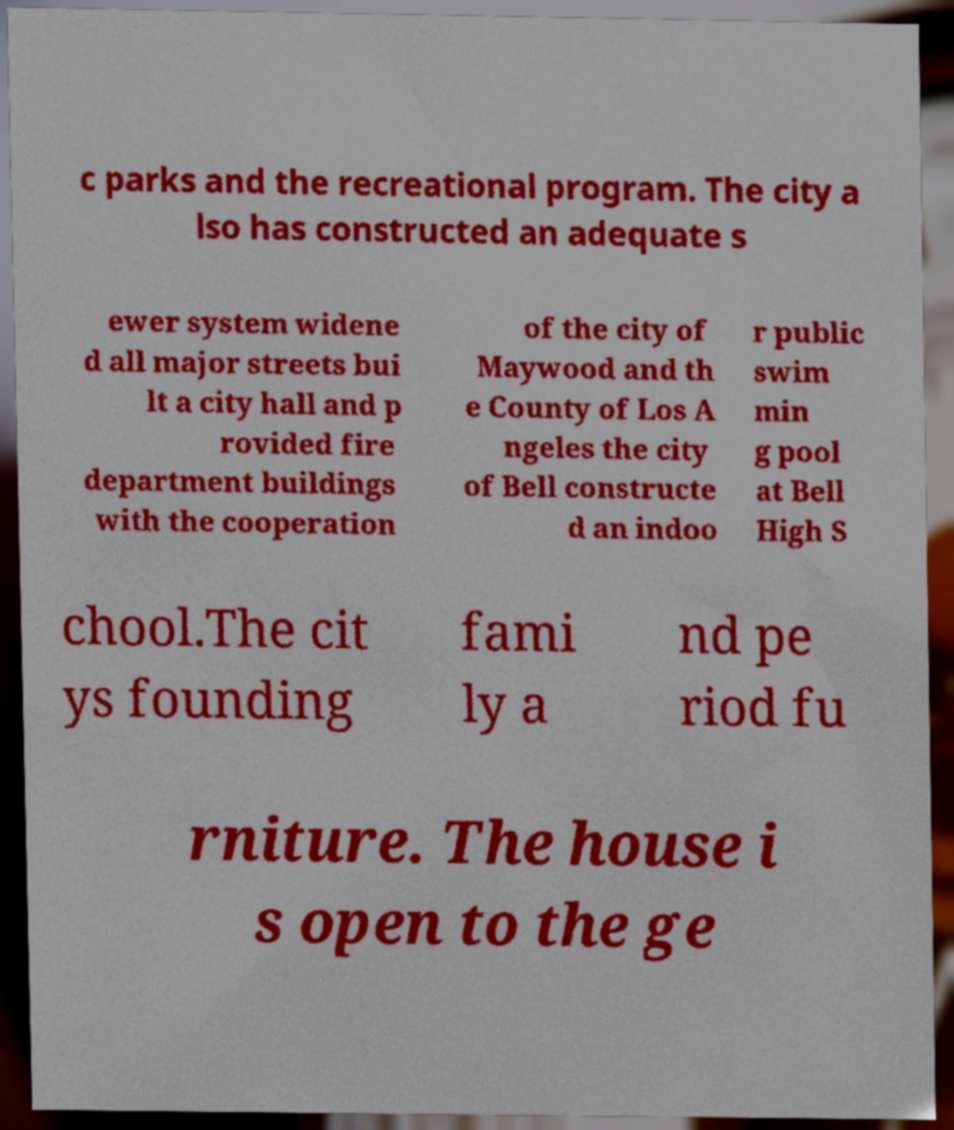What messages or text are displayed in this image? I need them in a readable, typed format. c parks and the recreational program. The city a lso has constructed an adequate s ewer system widene d all major streets bui lt a city hall and p rovided fire department buildings with the cooperation of the city of Maywood and th e County of Los A ngeles the city of Bell constructe d an indoo r public swim min g pool at Bell High S chool.The cit ys founding fami ly a nd pe riod fu rniture. The house i s open to the ge 